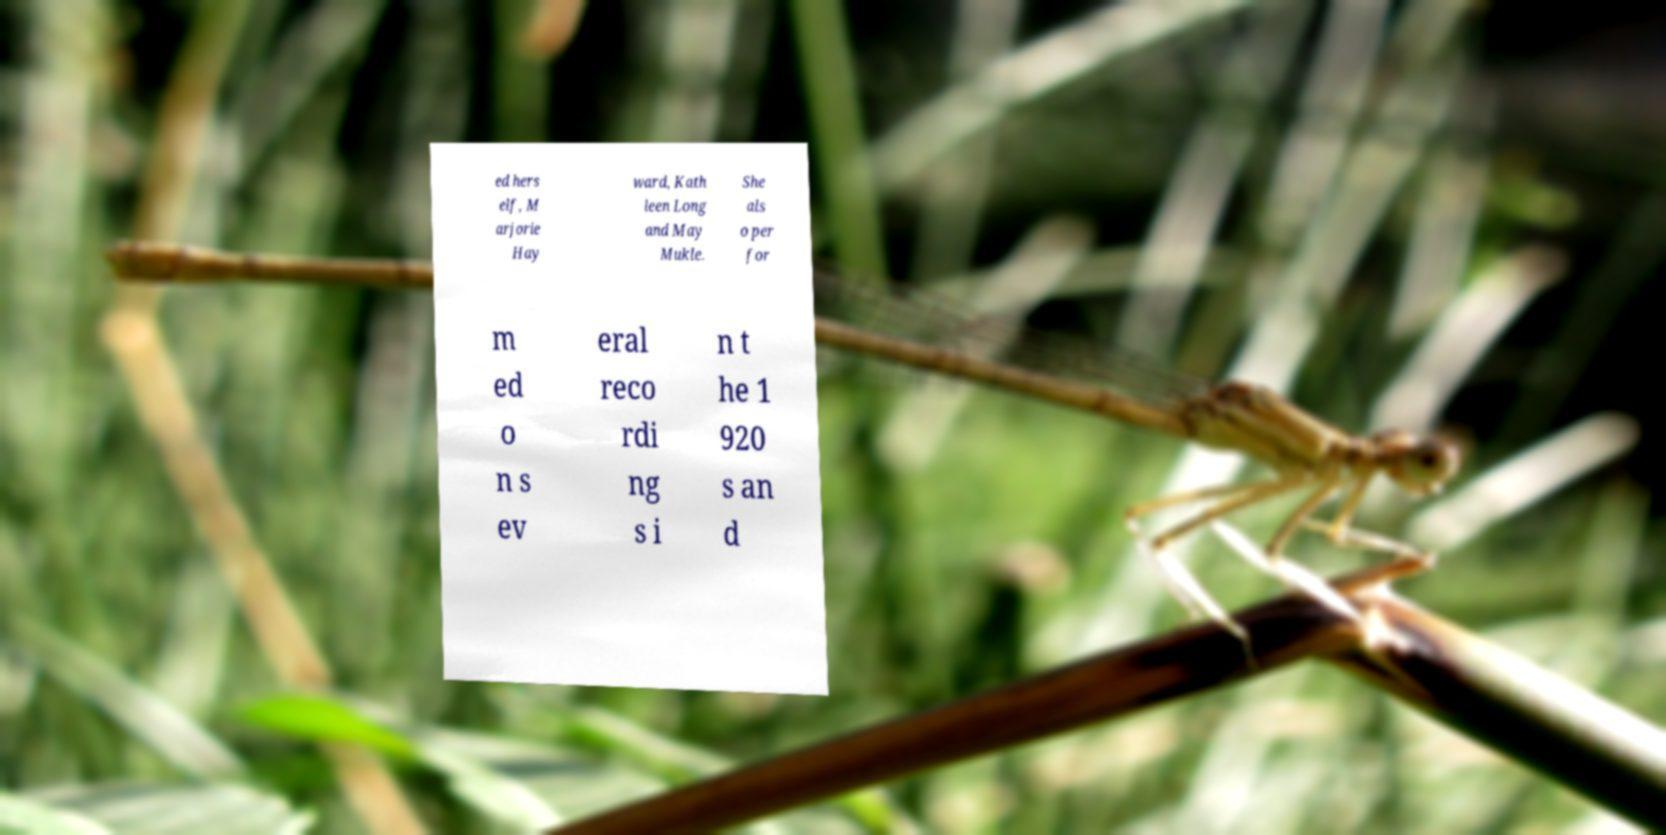Can you accurately transcribe the text from the provided image for me? ed hers elf, M arjorie Hay ward, Kath leen Long and May Mukle. She als o per for m ed o n s ev eral reco rdi ng s i n t he 1 920 s an d 